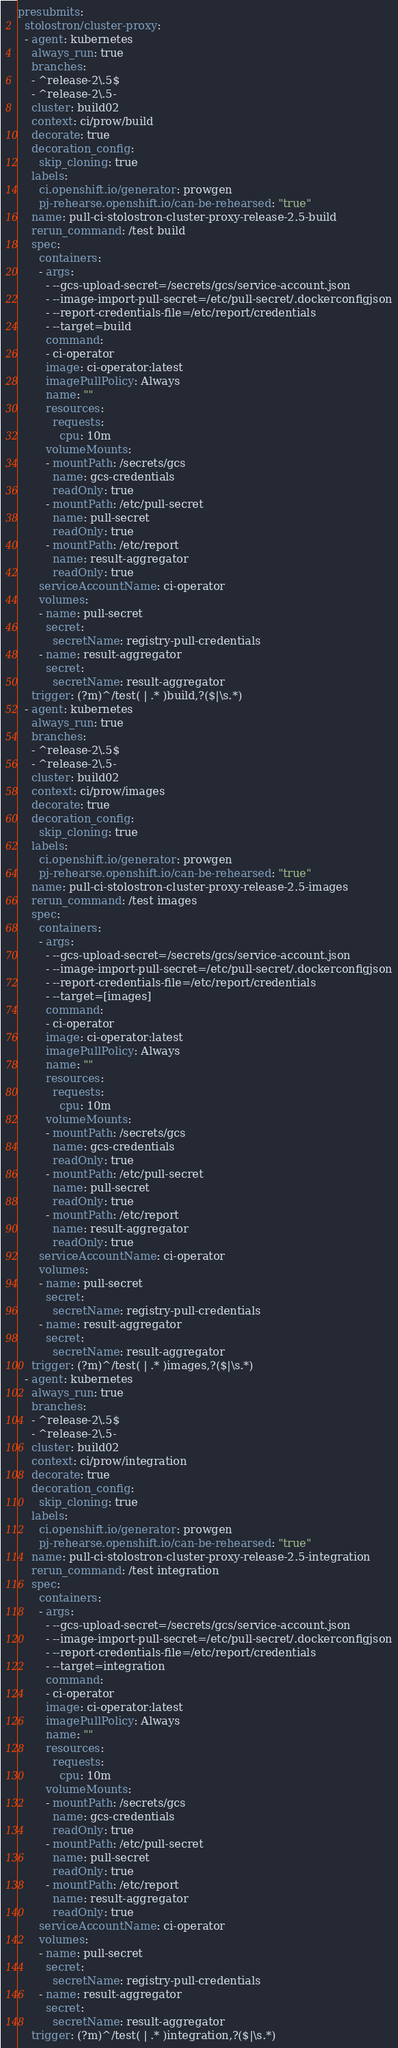<code> <loc_0><loc_0><loc_500><loc_500><_YAML_>presubmits:
  stolostron/cluster-proxy:
  - agent: kubernetes
    always_run: true
    branches:
    - ^release-2\.5$
    - ^release-2\.5-
    cluster: build02
    context: ci/prow/build
    decorate: true
    decoration_config:
      skip_cloning: true
    labels:
      ci.openshift.io/generator: prowgen
      pj-rehearse.openshift.io/can-be-rehearsed: "true"
    name: pull-ci-stolostron-cluster-proxy-release-2.5-build
    rerun_command: /test build
    spec:
      containers:
      - args:
        - --gcs-upload-secret=/secrets/gcs/service-account.json
        - --image-import-pull-secret=/etc/pull-secret/.dockerconfigjson
        - --report-credentials-file=/etc/report/credentials
        - --target=build
        command:
        - ci-operator
        image: ci-operator:latest
        imagePullPolicy: Always
        name: ""
        resources:
          requests:
            cpu: 10m
        volumeMounts:
        - mountPath: /secrets/gcs
          name: gcs-credentials
          readOnly: true
        - mountPath: /etc/pull-secret
          name: pull-secret
          readOnly: true
        - mountPath: /etc/report
          name: result-aggregator
          readOnly: true
      serviceAccountName: ci-operator
      volumes:
      - name: pull-secret
        secret:
          secretName: registry-pull-credentials
      - name: result-aggregator
        secret:
          secretName: result-aggregator
    trigger: (?m)^/test( | .* )build,?($|\s.*)
  - agent: kubernetes
    always_run: true
    branches:
    - ^release-2\.5$
    - ^release-2\.5-
    cluster: build02
    context: ci/prow/images
    decorate: true
    decoration_config:
      skip_cloning: true
    labels:
      ci.openshift.io/generator: prowgen
      pj-rehearse.openshift.io/can-be-rehearsed: "true"
    name: pull-ci-stolostron-cluster-proxy-release-2.5-images
    rerun_command: /test images
    spec:
      containers:
      - args:
        - --gcs-upload-secret=/secrets/gcs/service-account.json
        - --image-import-pull-secret=/etc/pull-secret/.dockerconfigjson
        - --report-credentials-file=/etc/report/credentials
        - --target=[images]
        command:
        - ci-operator
        image: ci-operator:latest
        imagePullPolicy: Always
        name: ""
        resources:
          requests:
            cpu: 10m
        volumeMounts:
        - mountPath: /secrets/gcs
          name: gcs-credentials
          readOnly: true
        - mountPath: /etc/pull-secret
          name: pull-secret
          readOnly: true
        - mountPath: /etc/report
          name: result-aggregator
          readOnly: true
      serviceAccountName: ci-operator
      volumes:
      - name: pull-secret
        secret:
          secretName: registry-pull-credentials
      - name: result-aggregator
        secret:
          secretName: result-aggregator
    trigger: (?m)^/test( | .* )images,?($|\s.*)
  - agent: kubernetes
    always_run: true
    branches:
    - ^release-2\.5$
    - ^release-2\.5-
    cluster: build02
    context: ci/prow/integration
    decorate: true
    decoration_config:
      skip_cloning: true
    labels:
      ci.openshift.io/generator: prowgen
      pj-rehearse.openshift.io/can-be-rehearsed: "true"
    name: pull-ci-stolostron-cluster-proxy-release-2.5-integration
    rerun_command: /test integration
    spec:
      containers:
      - args:
        - --gcs-upload-secret=/secrets/gcs/service-account.json
        - --image-import-pull-secret=/etc/pull-secret/.dockerconfigjson
        - --report-credentials-file=/etc/report/credentials
        - --target=integration
        command:
        - ci-operator
        image: ci-operator:latest
        imagePullPolicy: Always
        name: ""
        resources:
          requests:
            cpu: 10m
        volumeMounts:
        - mountPath: /secrets/gcs
          name: gcs-credentials
          readOnly: true
        - mountPath: /etc/pull-secret
          name: pull-secret
          readOnly: true
        - mountPath: /etc/report
          name: result-aggregator
          readOnly: true
      serviceAccountName: ci-operator
      volumes:
      - name: pull-secret
        secret:
          secretName: registry-pull-credentials
      - name: result-aggregator
        secret:
          secretName: result-aggregator
    trigger: (?m)^/test( | .* )integration,?($|\s.*)
</code> 